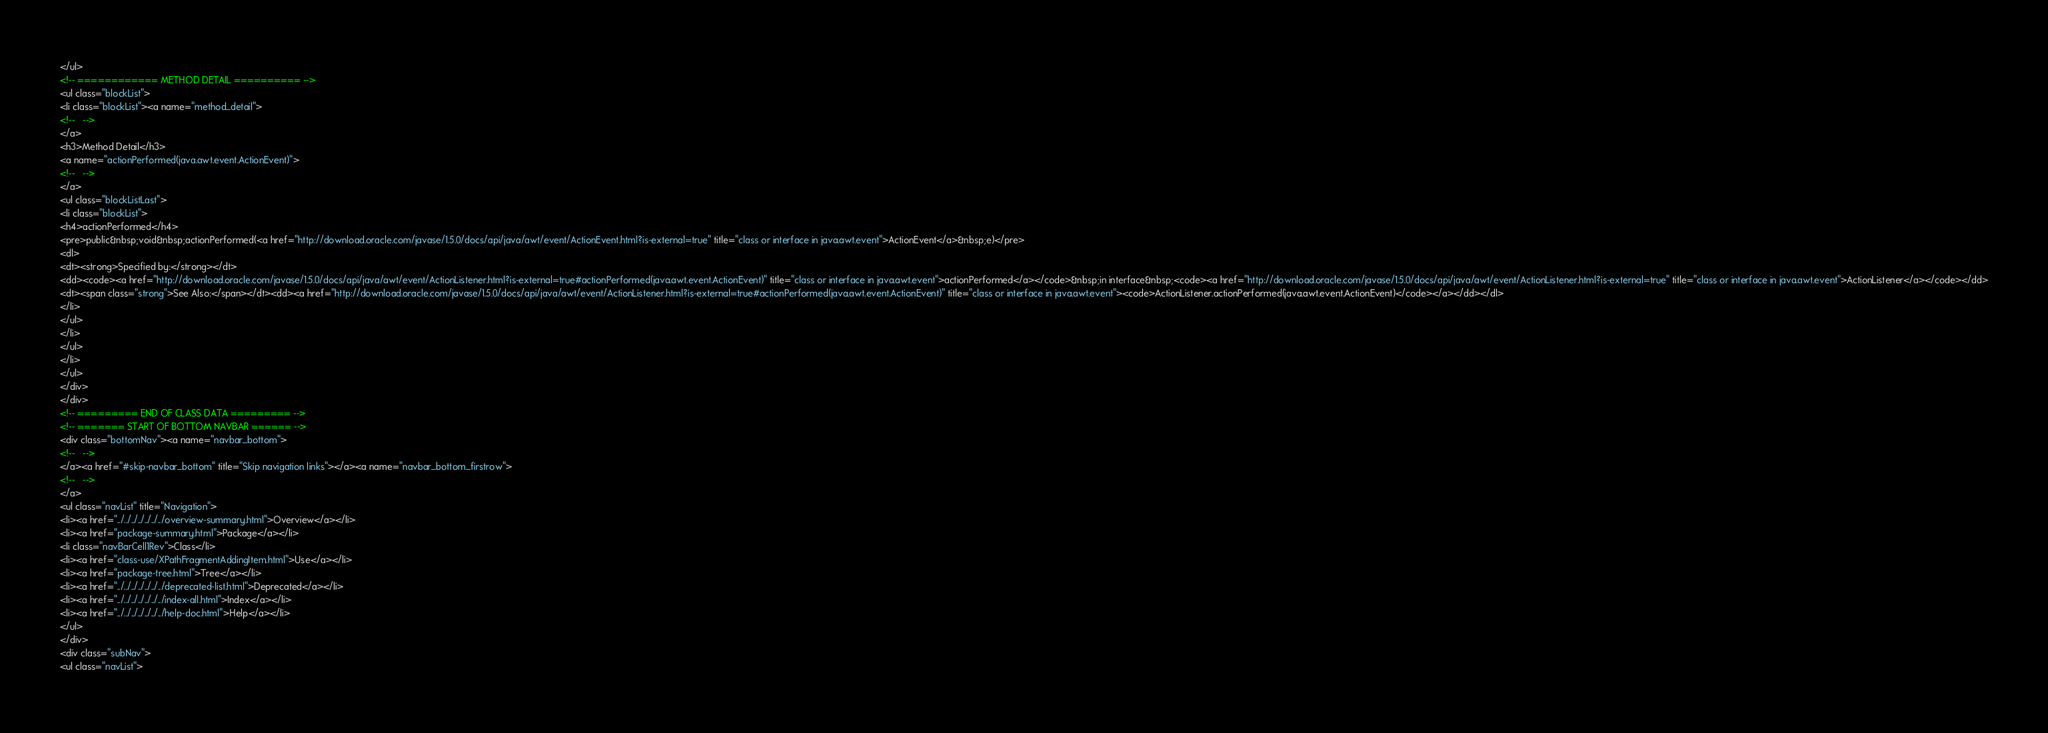Convert code to text. <code><loc_0><loc_0><loc_500><loc_500><_HTML_></ul>
<!-- ============ METHOD DETAIL ========== -->
<ul class="blockList">
<li class="blockList"><a name="method_detail">
<!--   -->
</a>
<h3>Method Detail</h3>
<a name="actionPerformed(java.awt.event.ActionEvent)">
<!--   -->
</a>
<ul class="blockListLast">
<li class="blockList">
<h4>actionPerformed</h4>
<pre>public&nbsp;void&nbsp;actionPerformed(<a href="http://download.oracle.com/javase/1.5.0/docs/api/java/awt/event/ActionEvent.html?is-external=true" title="class or interface in java.awt.event">ActionEvent</a>&nbsp;e)</pre>
<dl>
<dt><strong>Specified by:</strong></dt>
<dd><code><a href="http://download.oracle.com/javase/1.5.0/docs/api/java/awt/event/ActionListener.html?is-external=true#actionPerformed(java.awt.event.ActionEvent)" title="class or interface in java.awt.event">actionPerformed</a></code>&nbsp;in interface&nbsp;<code><a href="http://download.oracle.com/javase/1.5.0/docs/api/java/awt/event/ActionListener.html?is-external=true" title="class or interface in java.awt.event">ActionListener</a></code></dd>
<dt><span class="strong">See Also:</span></dt><dd><a href="http://download.oracle.com/javase/1.5.0/docs/api/java/awt/event/ActionListener.html?is-external=true#actionPerformed(java.awt.event.ActionEvent)" title="class or interface in java.awt.event"><code>ActionListener.actionPerformed(java.awt.event.ActionEvent)</code></a></dd></dl>
</li>
</ul>
</li>
</ul>
</li>
</ul>
</div>
</div>
<!-- ========= END OF CLASS DATA ========= -->
<!-- ======= START OF BOTTOM NAVBAR ====== -->
<div class="bottomNav"><a name="navbar_bottom">
<!--   -->
</a><a href="#skip-navbar_bottom" title="Skip navigation links"></a><a name="navbar_bottom_firstrow">
<!--   -->
</a>
<ul class="navList" title="Navigation">
<li><a href="../../../../../../../overview-summary.html">Overview</a></li>
<li><a href="package-summary.html">Package</a></li>
<li class="navBarCell1Rev">Class</li>
<li><a href="class-use/XPathFragmentAddingItem.html">Use</a></li>
<li><a href="package-tree.html">Tree</a></li>
<li><a href="../../../../../../../deprecated-list.html">Deprecated</a></li>
<li><a href="../../../../../../../index-all.html">Index</a></li>
<li><a href="../../../../../../../help-doc.html">Help</a></li>
</ul>
</div>
<div class="subNav">
<ul class="navList"></code> 